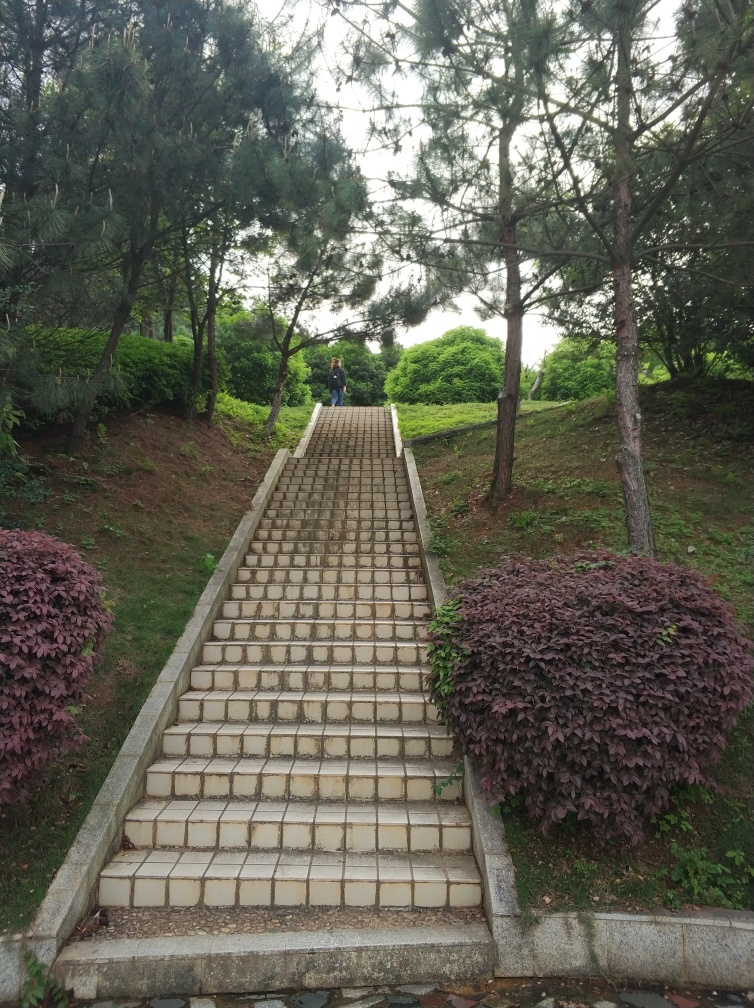Are the texture and details of the stairs rich and clear? Yes, the texture and details of the stairs are quite clear and well-defined, with the individual tiling patterns being visibly distinct. The photograph demonstrates good resolution, allowing the viewer to observe the worn-out edges on some of the tiles, and the variation in colors suggests some degree of weathering, which adds to the richness of detail. 